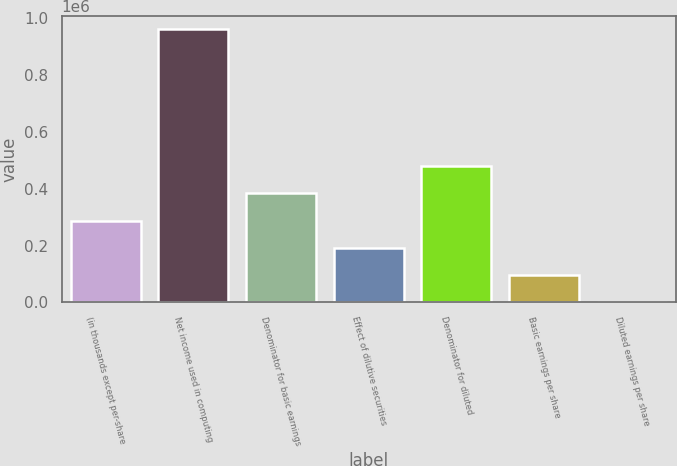<chart> <loc_0><loc_0><loc_500><loc_500><bar_chart><fcel>(in thousands except per-share<fcel>Net income used in computing<fcel>Denominator for basic earnings<fcel>Effect of dilutive securities<fcel>Denominator for diluted<fcel>Basic earnings per share<fcel>Diluted earnings per share<nl><fcel>287884<fcel>959604<fcel>383844<fcel>191924<fcel>479804<fcel>95963.5<fcel>3.41<nl></chart> 